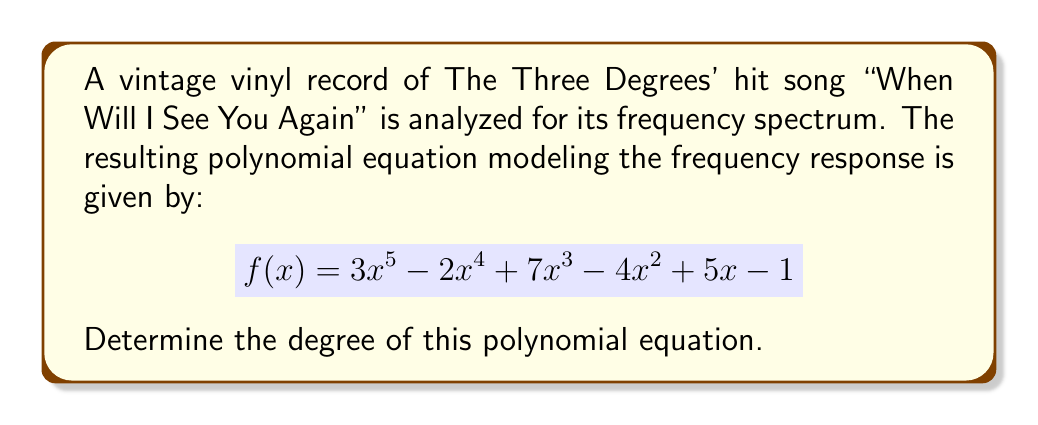Can you solve this math problem? To determine the degree of a polynomial equation, we need to identify the highest power of the variable in the equation. Let's examine the terms of the given polynomial:

1. $3x^5$: The exponent of x is 5
2. $-2x^4$: The exponent of x is 4
3. $7x^3$: The exponent of x is 3
4. $-4x^2$: The exponent of x is 2
5. $5x$: The exponent of x is 1 (often omitted in notation)
6. $-1$: This is a constant term, effectively $x^0$

The highest exponent among all terms is 5, which appears in the first term $3x^5$.

Therefore, the degree of the polynomial equation is 5.
Answer: 5 